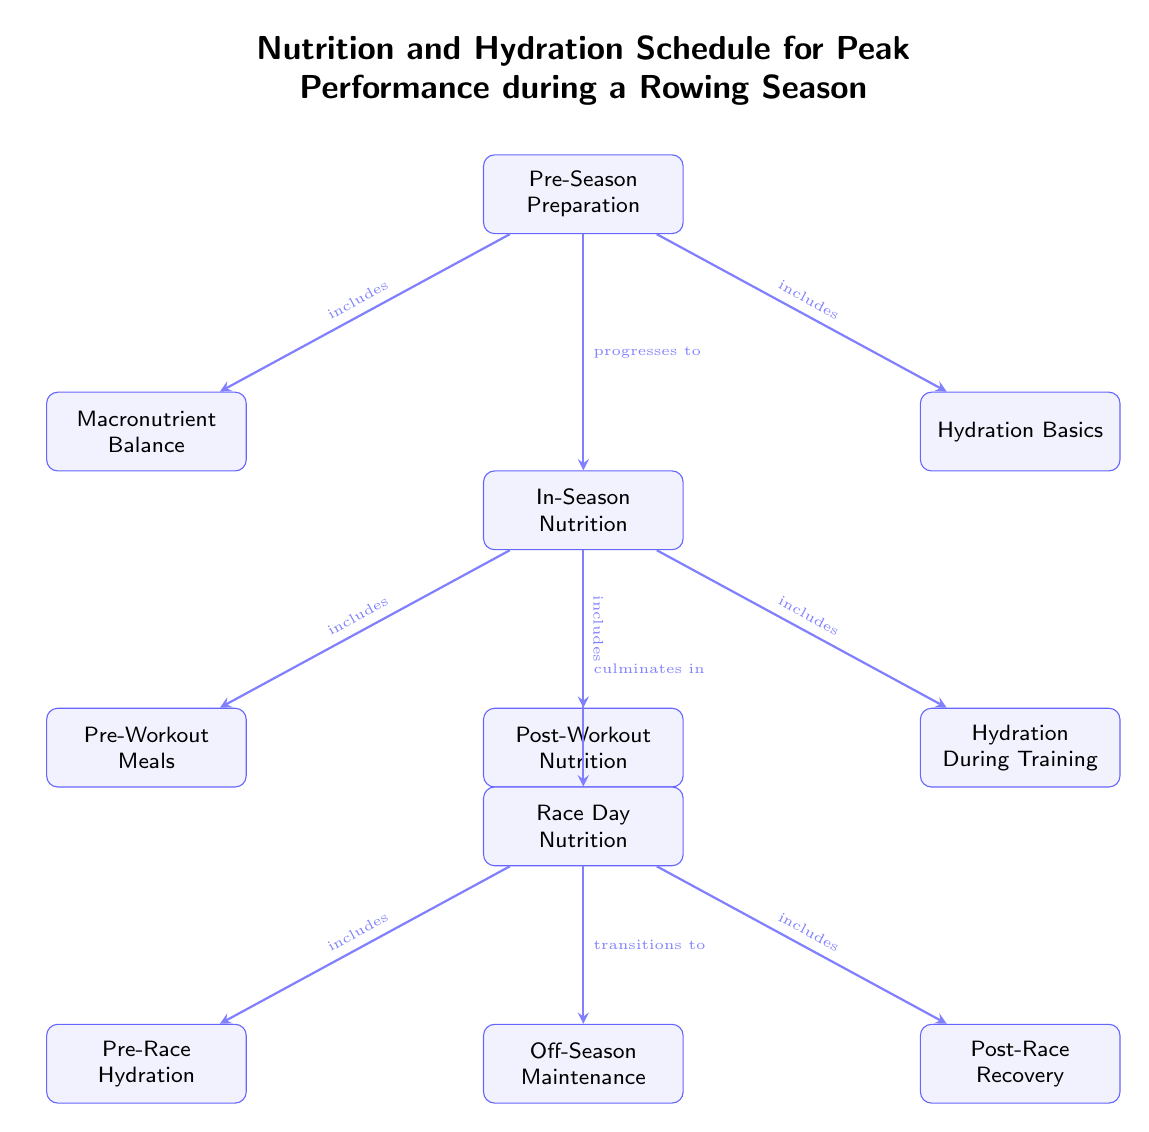What is the title of the diagram? The title is located at the top of the diagram and states the main focus of the content. It reads "Nutrition and Hydration Schedule for Peak Performance during a Rowing Season."
Answer: Nutrition and Hydration Schedule for Peak Performance during a Rowing Season How many main nodes are there in the diagram? To find the main nodes, count the number of rectangular boxes that are clearly defined in the diagram. There are a total of eight main nodes present, which include Pre-Season Preparation, In-Season Nutrition, Race Day Nutrition, and Off-Season Maintenance, among others.
Answer: Eight What does the "In-Season Nutrition" node include? By looking at the arrows pointing to "In-Season Nutrition," it is clear that this node includes Pre-Workout Meals, Post-Workout Nutrition, and Hydration During Training.
Answer: Pre-Workout Meals, Post-Workout Nutrition, Hydration During Training Which node progresses to "In-Season Nutrition"? To identify which node leads to "In-Season Nutrition," examine the direction of the arrows. The arrow from "Pre-Season Preparation" points to "In-Season Nutrition," indicating this relationship.
Answer: Pre-Season Preparation What are the two sub-nodes beneath "Race Day Nutrition"? Checking the nodes directly below "Race Day Nutrition," you'll find that the two sub-nodes are "Pre-Race Hydration" and "Post-Race Recovery."
Answer: Pre-Race Hydration, Post-Race Recovery What does "In-Season Nutrition" culminate in? The arrow pointing from "In-Season Nutrition" to "Race Day Nutrition" signifies that "In-Season Nutrition" culminates in this node. Therefore, the answer derives from analyzing this direct connection in the diagram.
Answer: Race Day Nutrition How is "Off-Season Maintenance" related to "Race Day Nutrition"? The diagram shows that "Off-Season Maintenance" transitions from "Race Day Nutrition." This means that after race day, focus shifts to off-season strategies, which indicates a sequential relationship.
Answer: Transitions from What does the "Pre-Season Preparation" node include? By examining the arrows that emanate from "Pre-Season Preparation," we can identify that this node includes both "Macronutrient Balance" and "Hydration Basics."
Answer: Macronutrient Balance, Hydration Basics 